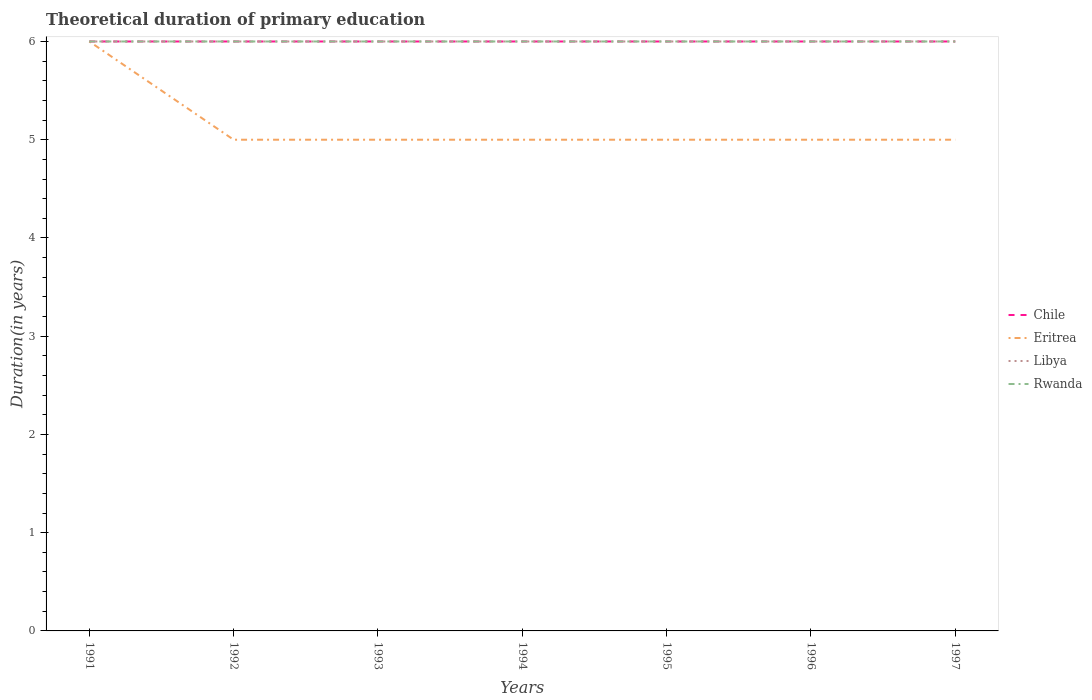Does the line corresponding to Chile intersect with the line corresponding to Eritrea?
Offer a very short reply. Yes. In which year was the total theoretical duration of primary education in Eritrea maximum?
Your response must be concise. 1992. What is the total total theoretical duration of primary education in Libya in the graph?
Offer a terse response. 0. What is the difference between the highest and the second highest total theoretical duration of primary education in Chile?
Make the answer very short. 0. What is the difference between the highest and the lowest total theoretical duration of primary education in Rwanda?
Your answer should be very brief. 0. How many lines are there?
Keep it short and to the point. 4. How many years are there in the graph?
Keep it short and to the point. 7. What is the difference between two consecutive major ticks on the Y-axis?
Provide a short and direct response. 1. Where does the legend appear in the graph?
Offer a terse response. Center right. How are the legend labels stacked?
Your answer should be very brief. Vertical. What is the title of the graph?
Give a very brief answer. Theoretical duration of primary education. What is the label or title of the X-axis?
Offer a very short reply. Years. What is the label or title of the Y-axis?
Give a very brief answer. Duration(in years). What is the Duration(in years) of Chile in 1991?
Provide a succinct answer. 6. What is the Duration(in years) in Eritrea in 1991?
Provide a succinct answer. 6. What is the Duration(in years) of Libya in 1991?
Offer a terse response. 6. What is the Duration(in years) of Rwanda in 1991?
Your answer should be very brief. 6. What is the Duration(in years) of Chile in 1992?
Make the answer very short. 6. What is the Duration(in years) of Eritrea in 1992?
Ensure brevity in your answer.  5. What is the Duration(in years) in Libya in 1992?
Make the answer very short. 6. What is the Duration(in years) of Rwanda in 1992?
Give a very brief answer. 6. What is the Duration(in years) of Rwanda in 1993?
Keep it short and to the point. 6. What is the Duration(in years) of Eritrea in 1994?
Make the answer very short. 5. What is the Duration(in years) in Eritrea in 1995?
Ensure brevity in your answer.  5. What is the Duration(in years) in Libya in 1995?
Your answer should be compact. 6. What is the Duration(in years) of Rwanda in 1995?
Give a very brief answer. 6. What is the Duration(in years) in Eritrea in 1996?
Your answer should be very brief. 5. What is the Duration(in years) in Rwanda in 1996?
Your answer should be very brief. 6. What is the Duration(in years) of Libya in 1997?
Ensure brevity in your answer.  6. Across all years, what is the maximum Duration(in years) of Chile?
Your answer should be compact. 6. Across all years, what is the maximum Duration(in years) in Eritrea?
Your response must be concise. 6. Across all years, what is the minimum Duration(in years) in Chile?
Keep it short and to the point. 6. Across all years, what is the minimum Duration(in years) in Rwanda?
Provide a succinct answer. 6. What is the total Duration(in years) in Chile in the graph?
Provide a short and direct response. 42. What is the total Duration(in years) in Eritrea in the graph?
Ensure brevity in your answer.  36. What is the difference between the Duration(in years) in Libya in 1991 and that in 1992?
Ensure brevity in your answer.  0. What is the difference between the Duration(in years) in Chile in 1991 and that in 1993?
Offer a very short reply. 0. What is the difference between the Duration(in years) of Eritrea in 1991 and that in 1993?
Keep it short and to the point. 1. What is the difference between the Duration(in years) of Libya in 1991 and that in 1993?
Provide a short and direct response. 0. What is the difference between the Duration(in years) of Chile in 1991 and that in 1994?
Keep it short and to the point. 0. What is the difference between the Duration(in years) in Rwanda in 1991 and that in 1994?
Your answer should be very brief. 0. What is the difference between the Duration(in years) of Libya in 1991 and that in 1995?
Your answer should be compact. 0. What is the difference between the Duration(in years) in Libya in 1991 and that in 1996?
Provide a short and direct response. 0. What is the difference between the Duration(in years) in Chile in 1991 and that in 1997?
Keep it short and to the point. 0. What is the difference between the Duration(in years) of Libya in 1992 and that in 1993?
Provide a succinct answer. 0. What is the difference between the Duration(in years) of Rwanda in 1992 and that in 1993?
Ensure brevity in your answer.  0. What is the difference between the Duration(in years) in Rwanda in 1992 and that in 1994?
Give a very brief answer. 0. What is the difference between the Duration(in years) in Chile in 1992 and that in 1995?
Provide a short and direct response. 0. What is the difference between the Duration(in years) in Eritrea in 1992 and that in 1995?
Ensure brevity in your answer.  0. What is the difference between the Duration(in years) in Chile in 1992 and that in 1996?
Provide a short and direct response. 0. What is the difference between the Duration(in years) in Rwanda in 1992 and that in 1996?
Provide a succinct answer. 0. What is the difference between the Duration(in years) in Libya in 1993 and that in 1994?
Make the answer very short. 0. What is the difference between the Duration(in years) in Eritrea in 1993 and that in 1995?
Provide a succinct answer. 0. What is the difference between the Duration(in years) in Eritrea in 1993 and that in 1996?
Your answer should be compact. 0. What is the difference between the Duration(in years) in Rwanda in 1993 and that in 1996?
Your answer should be compact. 0. What is the difference between the Duration(in years) of Chile in 1993 and that in 1997?
Provide a succinct answer. 0. What is the difference between the Duration(in years) in Eritrea in 1993 and that in 1997?
Keep it short and to the point. 0. What is the difference between the Duration(in years) in Libya in 1993 and that in 1997?
Offer a very short reply. 0. What is the difference between the Duration(in years) in Chile in 1994 and that in 1995?
Your answer should be very brief. 0. What is the difference between the Duration(in years) of Libya in 1994 and that in 1996?
Offer a terse response. 0. What is the difference between the Duration(in years) in Rwanda in 1994 and that in 1996?
Make the answer very short. 0. What is the difference between the Duration(in years) of Chile in 1994 and that in 1997?
Ensure brevity in your answer.  0. What is the difference between the Duration(in years) of Eritrea in 1994 and that in 1997?
Offer a terse response. 0. What is the difference between the Duration(in years) in Libya in 1994 and that in 1997?
Offer a very short reply. 0. What is the difference between the Duration(in years) in Rwanda in 1994 and that in 1997?
Offer a very short reply. 0. What is the difference between the Duration(in years) in Chile in 1995 and that in 1996?
Your answer should be very brief. 0. What is the difference between the Duration(in years) of Eritrea in 1995 and that in 1996?
Offer a very short reply. 0. What is the difference between the Duration(in years) in Libya in 1995 and that in 1996?
Your answer should be compact. 0. What is the difference between the Duration(in years) of Rwanda in 1995 and that in 1996?
Your answer should be compact. 0. What is the difference between the Duration(in years) of Libya in 1996 and that in 1997?
Keep it short and to the point. 0. What is the difference between the Duration(in years) of Rwanda in 1996 and that in 1997?
Provide a succinct answer. 0. What is the difference between the Duration(in years) of Eritrea in 1991 and the Duration(in years) of Libya in 1992?
Give a very brief answer. 0. What is the difference between the Duration(in years) of Eritrea in 1991 and the Duration(in years) of Rwanda in 1992?
Offer a very short reply. 0. What is the difference between the Duration(in years) of Libya in 1991 and the Duration(in years) of Rwanda in 1992?
Your answer should be very brief. 0. What is the difference between the Duration(in years) of Chile in 1991 and the Duration(in years) of Libya in 1993?
Ensure brevity in your answer.  0. What is the difference between the Duration(in years) in Chile in 1991 and the Duration(in years) in Rwanda in 1993?
Make the answer very short. 0. What is the difference between the Duration(in years) of Eritrea in 1991 and the Duration(in years) of Rwanda in 1993?
Keep it short and to the point. 0. What is the difference between the Duration(in years) in Libya in 1991 and the Duration(in years) in Rwanda in 1993?
Your answer should be compact. 0. What is the difference between the Duration(in years) in Chile in 1991 and the Duration(in years) in Rwanda in 1994?
Keep it short and to the point. 0. What is the difference between the Duration(in years) in Eritrea in 1991 and the Duration(in years) in Rwanda in 1994?
Make the answer very short. 0. What is the difference between the Duration(in years) of Libya in 1991 and the Duration(in years) of Rwanda in 1994?
Offer a very short reply. 0. What is the difference between the Duration(in years) in Chile in 1991 and the Duration(in years) in Libya in 1995?
Your answer should be very brief. 0. What is the difference between the Duration(in years) of Chile in 1991 and the Duration(in years) of Rwanda in 1995?
Offer a terse response. 0. What is the difference between the Duration(in years) of Eritrea in 1991 and the Duration(in years) of Libya in 1995?
Give a very brief answer. 0. What is the difference between the Duration(in years) of Libya in 1991 and the Duration(in years) of Rwanda in 1995?
Provide a succinct answer. 0. What is the difference between the Duration(in years) in Chile in 1991 and the Duration(in years) in Rwanda in 1996?
Provide a short and direct response. 0. What is the difference between the Duration(in years) in Eritrea in 1991 and the Duration(in years) in Libya in 1996?
Provide a short and direct response. 0. What is the difference between the Duration(in years) in Eritrea in 1991 and the Duration(in years) in Rwanda in 1996?
Your answer should be very brief. 0. What is the difference between the Duration(in years) of Chile in 1991 and the Duration(in years) of Eritrea in 1997?
Keep it short and to the point. 1. What is the difference between the Duration(in years) in Eritrea in 1991 and the Duration(in years) in Rwanda in 1997?
Provide a succinct answer. 0. What is the difference between the Duration(in years) in Chile in 1992 and the Duration(in years) in Libya in 1993?
Provide a short and direct response. 0. What is the difference between the Duration(in years) in Eritrea in 1992 and the Duration(in years) in Libya in 1993?
Provide a succinct answer. -1. What is the difference between the Duration(in years) of Chile in 1992 and the Duration(in years) of Eritrea in 1994?
Keep it short and to the point. 1. What is the difference between the Duration(in years) of Eritrea in 1992 and the Duration(in years) of Libya in 1994?
Give a very brief answer. -1. What is the difference between the Duration(in years) in Libya in 1992 and the Duration(in years) in Rwanda in 1994?
Provide a short and direct response. 0. What is the difference between the Duration(in years) of Chile in 1992 and the Duration(in years) of Libya in 1995?
Your answer should be compact. 0. What is the difference between the Duration(in years) in Eritrea in 1992 and the Duration(in years) in Libya in 1995?
Provide a short and direct response. -1. What is the difference between the Duration(in years) of Eritrea in 1992 and the Duration(in years) of Rwanda in 1995?
Your answer should be compact. -1. What is the difference between the Duration(in years) in Libya in 1992 and the Duration(in years) in Rwanda in 1995?
Your response must be concise. 0. What is the difference between the Duration(in years) of Chile in 1992 and the Duration(in years) of Libya in 1996?
Provide a succinct answer. 0. What is the difference between the Duration(in years) in Eritrea in 1992 and the Duration(in years) in Libya in 1996?
Provide a succinct answer. -1. What is the difference between the Duration(in years) of Eritrea in 1992 and the Duration(in years) of Rwanda in 1996?
Make the answer very short. -1. What is the difference between the Duration(in years) in Libya in 1992 and the Duration(in years) in Rwanda in 1996?
Keep it short and to the point. 0. What is the difference between the Duration(in years) in Libya in 1992 and the Duration(in years) in Rwanda in 1997?
Your answer should be very brief. 0. What is the difference between the Duration(in years) in Chile in 1993 and the Duration(in years) in Eritrea in 1994?
Make the answer very short. 1. What is the difference between the Duration(in years) in Chile in 1993 and the Duration(in years) in Libya in 1994?
Make the answer very short. 0. What is the difference between the Duration(in years) in Chile in 1993 and the Duration(in years) in Rwanda in 1994?
Keep it short and to the point. 0. What is the difference between the Duration(in years) in Eritrea in 1993 and the Duration(in years) in Libya in 1994?
Your response must be concise. -1. What is the difference between the Duration(in years) of Eritrea in 1993 and the Duration(in years) of Rwanda in 1994?
Provide a succinct answer. -1. What is the difference between the Duration(in years) of Chile in 1993 and the Duration(in years) of Eritrea in 1995?
Offer a very short reply. 1. What is the difference between the Duration(in years) in Chile in 1993 and the Duration(in years) in Rwanda in 1995?
Your answer should be compact. 0. What is the difference between the Duration(in years) in Chile in 1993 and the Duration(in years) in Eritrea in 1996?
Ensure brevity in your answer.  1. What is the difference between the Duration(in years) of Eritrea in 1993 and the Duration(in years) of Libya in 1996?
Offer a terse response. -1. What is the difference between the Duration(in years) in Chile in 1993 and the Duration(in years) in Libya in 1997?
Keep it short and to the point. 0. What is the difference between the Duration(in years) of Eritrea in 1993 and the Duration(in years) of Libya in 1997?
Provide a short and direct response. -1. What is the difference between the Duration(in years) in Libya in 1993 and the Duration(in years) in Rwanda in 1997?
Make the answer very short. 0. What is the difference between the Duration(in years) of Chile in 1994 and the Duration(in years) of Eritrea in 1995?
Offer a very short reply. 1. What is the difference between the Duration(in years) of Eritrea in 1994 and the Duration(in years) of Libya in 1995?
Ensure brevity in your answer.  -1. What is the difference between the Duration(in years) in Eritrea in 1994 and the Duration(in years) in Rwanda in 1995?
Provide a succinct answer. -1. What is the difference between the Duration(in years) of Libya in 1994 and the Duration(in years) of Rwanda in 1995?
Ensure brevity in your answer.  0. What is the difference between the Duration(in years) of Chile in 1994 and the Duration(in years) of Libya in 1996?
Your answer should be compact. 0. What is the difference between the Duration(in years) in Chile in 1994 and the Duration(in years) in Rwanda in 1996?
Keep it short and to the point. 0. What is the difference between the Duration(in years) in Eritrea in 1994 and the Duration(in years) in Libya in 1996?
Your response must be concise. -1. What is the difference between the Duration(in years) of Libya in 1994 and the Duration(in years) of Rwanda in 1996?
Your answer should be compact. 0. What is the difference between the Duration(in years) in Chile in 1994 and the Duration(in years) in Libya in 1997?
Your answer should be very brief. 0. What is the difference between the Duration(in years) in Chile in 1994 and the Duration(in years) in Rwanda in 1997?
Provide a succinct answer. 0. What is the difference between the Duration(in years) of Eritrea in 1994 and the Duration(in years) of Libya in 1997?
Make the answer very short. -1. What is the difference between the Duration(in years) in Chile in 1995 and the Duration(in years) in Eritrea in 1996?
Ensure brevity in your answer.  1. What is the difference between the Duration(in years) in Chile in 1995 and the Duration(in years) in Libya in 1996?
Make the answer very short. 0. What is the difference between the Duration(in years) of Chile in 1995 and the Duration(in years) of Rwanda in 1996?
Give a very brief answer. 0. What is the difference between the Duration(in years) in Chile in 1995 and the Duration(in years) in Eritrea in 1997?
Offer a very short reply. 1. What is the difference between the Duration(in years) in Eritrea in 1995 and the Duration(in years) in Libya in 1997?
Offer a terse response. -1. What is the difference between the Duration(in years) in Libya in 1995 and the Duration(in years) in Rwanda in 1997?
Provide a succinct answer. 0. What is the difference between the Duration(in years) of Chile in 1996 and the Duration(in years) of Rwanda in 1997?
Ensure brevity in your answer.  0. What is the average Duration(in years) of Chile per year?
Your answer should be very brief. 6. What is the average Duration(in years) in Eritrea per year?
Your answer should be compact. 5.14. In the year 1991, what is the difference between the Duration(in years) of Chile and Duration(in years) of Eritrea?
Give a very brief answer. 0. In the year 1991, what is the difference between the Duration(in years) in Chile and Duration(in years) in Libya?
Provide a succinct answer. 0. In the year 1991, what is the difference between the Duration(in years) in Chile and Duration(in years) in Rwanda?
Ensure brevity in your answer.  0. In the year 1991, what is the difference between the Duration(in years) in Eritrea and Duration(in years) in Rwanda?
Give a very brief answer. 0. In the year 1991, what is the difference between the Duration(in years) of Libya and Duration(in years) of Rwanda?
Keep it short and to the point. 0. In the year 1992, what is the difference between the Duration(in years) of Chile and Duration(in years) of Eritrea?
Your answer should be compact. 1. In the year 1992, what is the difference between the Duration(in years) in Eritrea and Duration(in years) in Rwanda?
Your answer should be very brief. -1. In the year 1992, what is the difference between the Duration(in years) of Libya and Duration(in years) of Rwanda?
Ensure brevity in your answer.  0. In the year 1994, what is the difference between the Duration(in years) of Chile and Duration(in years) of Libya?
Your answer should be very brief. 0. In the year 1994, what is the difference between the Duration(in years) in Chile and Duration(in years) in Rwanda?
Give a very brief answer. 0. In the year 1994, what is the difference between the Duration(in years) in Eritrea and Duration(in years) in Libya?
Provide a succinct answer. -1. In the year 1994, what is the difference between the Duration(in years) of Eritrea and Duration(in years) of Rwanda?
Make the answer very short. -1. In the year 1994, what is the difference between the Duration(in years) of Libya and Duration(in years) of Rwanda?
Give a very brief answer. 0. In the year 1995, what is the difference between the Duration(in years) of Chile and Duration(in years) of Libya?
Your answer should be compact. 0. In the year 1995, what is the difference between the Duration(in years) of Chile and Duration(in years) of Rwanda?
Your response must be concise. 0. In the year 1995, what is the difference between the Duration(in years) of Eritrea and Duration(in years) of Rwanda?
Your response must be concise. -1. In the year 1996, what is the difference between the Duration(in years) of Chile and Duration(in years) of Eritrea?
Ensure brevity in your answer.  1. In the year 1996, what is the difference between the Duration(in years) of Chile and Duration(in years) of Rwanda?
Your response must be concise. 0. In the year 1996, what is the difference between the Duration(in years) of Eritrea and Duration(in years) of Rwanda?
Offer a terse response. -1. In the year 1996, what is the difference between the Duration(in years) in Libya and Duration(in years) in Rwanda?
Ensure brevity in your answer.  0. In the year 1997, what is the difference between the Duration(in years) in Chile and Duration(in years) in Rwanda?
Your answer should be compact. 0. In the year 1997, what is the difference between the Duration(in years) in Eritrea and Duration(in years) in Rwanda?
Keep it short and to the point. -1. In the year 1997, what is the difference between the Duration(in years) of Libya and Duration(in years) of Rwanda?
Your answer should be very brief. 0. What is the ratio of the Duration(in years) in Libya in 1991 to that in 1992?
Your response must be concise. 1. What is the ratio of the Duration(in years) of Rwanda in 1991 to that in 1992?
Keep it short and to the point. 1. What is the ratio of the Duration(in years) of Chile in 1991 to that in 1993?
Give a very brief answer. 1. What is the ratio of the Duration(in years) in Eritrea in 1991 to that in 1993?
Provide a succinct answer. 1.2. What is the ratio of the Duration(in years) of Chile in 1991 to that in 1994?
Give a very brief answer. 1. What is the ratio of the Duration(in years) in Eritrea in 1991 to that in 1994?
Provide a short and direct response. 1.2. What is the ratio of the Duration(in years) of Rwanda in 1991 to that in 1994?
Make the answer very short. 1. What is the ratio of the Duration(in years) in Chile in 1991 to that in 1995?
Keep it short and to the point. 1. What is the ratio of the Duration(in years) in Chile in 1991 to that in 1996?
Ensure brevity in your answer.  1. What is the ratio of the Duration(in years) of Libya in 1991 to that in 1996?
Your answer should be compact. 1. What is the ratio of the Duration(in years) in Rwanda in 1992 to that in 1993?
Give a very brief answer. 1. What is the ratio of the Duration(in years) in Libya in 1992 to that in 1994?
Your answer should be compact. 1. What is the ratio of the Duration(in years) in Chile in 1992 to that in 1995?
Give a very brief answer. 1. What is the ratio of the Duration(in years) in Eritrea in 1992 to that in 1995?
Ensure brevity in your answer.  1. What is the ratio of the Duration(in years) of Rwanda in 1992 to that in 1995?
Give a very brief answer. 1. What is the ratio of the Duration(in years) in Eritrea in 1992 to that in 1996?
Offer a very short reply. 1. What is the ratio of the Duration(in years) of Libya in 1992 to that in 1997?
Keep it short and to the point. 1. What is the ratio of the Duration(in years) in Eritrea in 1993 to that in 1994?
Keep it short and to the point. 1. What is the ratio of the Duration(in years) in Libya in 1993 to that in 1995?
Make the answer very short. 1. What is the ratio of the Duration(in years) in Rwanda in 1993 to that in 1995?
Your answer should be compact. 1. What is the ratio of the Duration(in years) in Chile in 1993 to that in 1996?
Give a very brief answer. 1. What is the ratio of the Duration(in years) in Libya in 1993 to that in 1996?
Provide a short and direct response. 1. What is the ratio of the Duration(in years) of Rwanda in 1993 to that in 1996?
Keep it short and to the point. 1. What is the ratio of the Duration(in years) of Chile in 1993 to that in 1997?
Provide a short and direct response. 1. What is the ratio of the Duration(in years) in Eritrea in 1993 to that in 1997?
Offer a terse response. 1. What is the ratio of the Duration(in years) of Rwanda in 1993 to that in 1997?
Offer a very short reply. 1. What is the ratio of the Duration(in years) in Libya in 1994 to that in 1995?
Offer a very short reply. 1. What is the ratio of the Duration(in years) of Eritrea in 1994 to that in 1996?
Provide a short and direct response. 1. What is the ratio of the Duration(in years) of Rwanda in 1994 to that in 1996?
Keep it short and to the point. 1. What is the ratio of the Duration(in years) in Chile in 1994 to that in 1997?
Ensure brevity in your answer.  1. What is the ratio of the Duration(in years) of Eritrea in 1995 to that in 1996?
Provide a short and direct response. 1. What is the ratio of the Duration(in years) of Libya in 1995 to that in 1996?
Offer a very short reply. 1. What is the ratio of the Duration(in years) in Rwanda in 1995 to that in 1996?
Your response must be concise. 1. What is the ratio of the Duration(in years) of Chile in 1995 to that in 1997?
Make the answer very short. 1. What is the ratio of the Duration(in years) of Chile in 1996 to that in 1997?
Your answer should be compact. 1. What is the ratio of the Duration(in years) of Eritrea in 1996 to that in 1997?
Make the answer very short. 1. What is the ratio of the Duration(in years) in Libya in 1996 to that in 1997?
Make the answer very short. 1. What is the difference between the highest and the second highest Duration(in years) in Chile?
Offer a very short reply. 0. What is the difference between the highest and the second highest Duration(in years) of Eritrea?
Ensure brevity in your answer.  1. What is the difference between the highest and the second highest Duration(in years) of Libya?
Give a very brief answer. 0. What is the difference between the highest and the second highest Duration(in years) in Rwanda?
Provide a short and direct response. 0. What is the difference between the highest and the lowest Duration(in years) in Eritrea?
Offer a terse response. 1. 